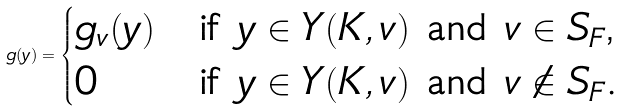Convert formula to latex. <formula><loc_0><loc_0><loc_500><loc_500>g ( y ) = \begin{cases} g _ { v } ( y ) & \text {if $y\in Y(K,v)$ and $v\in S_{F}$,} \\ 0 & \text {if $y\in Y(K,v)$ and $v\notin S_{F}$.} \end{cases}</formula> 